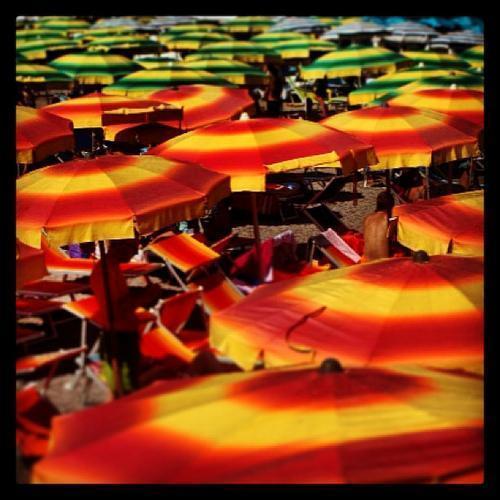How many colors does each umbrella have?
Give a very brief answer. 2. 